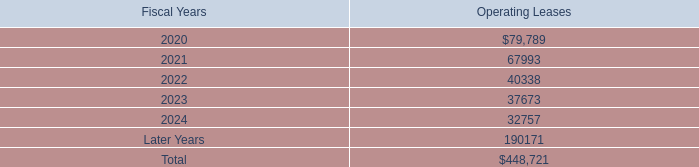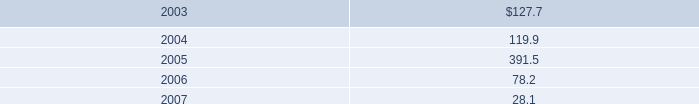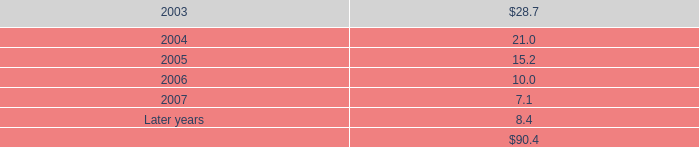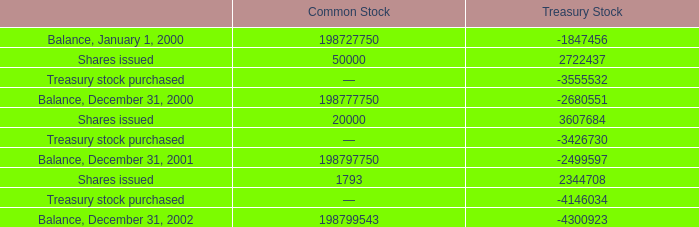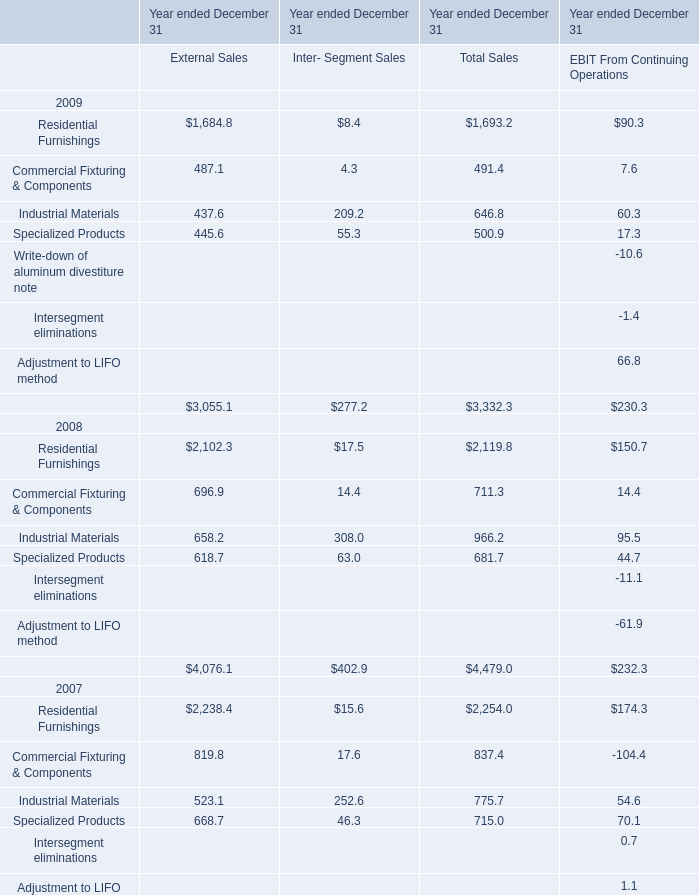what percentage has renting lease expenses increased from 2017 to 2019? 
Computations: ((92.3 - 58.8) / 58.8)
Answer: 0.56973. 